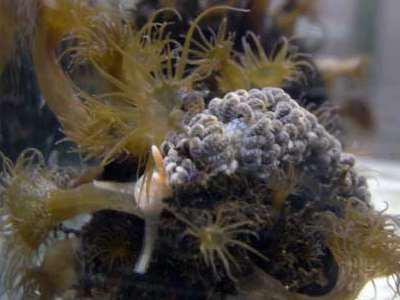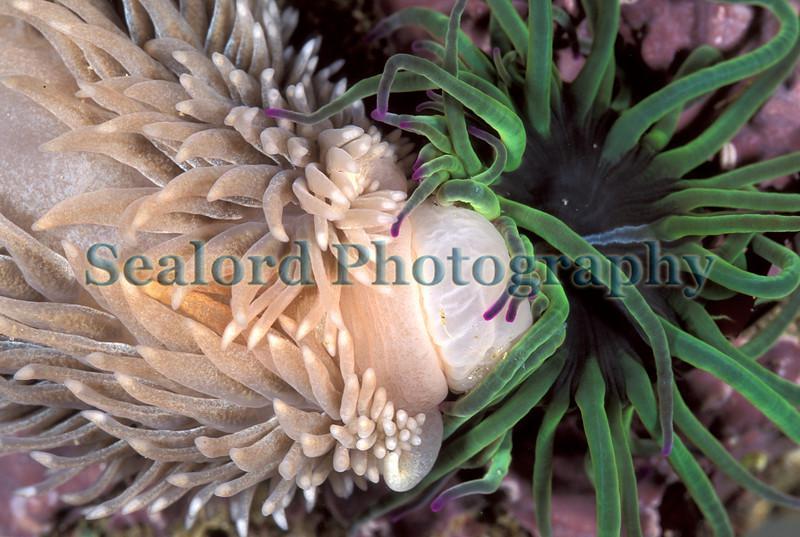The first image is the image on the left, the second image is the image on the right. For the images displayed, is the sentence "The creatures in each image are the same color" factually correct? Answer yes or no. No. 